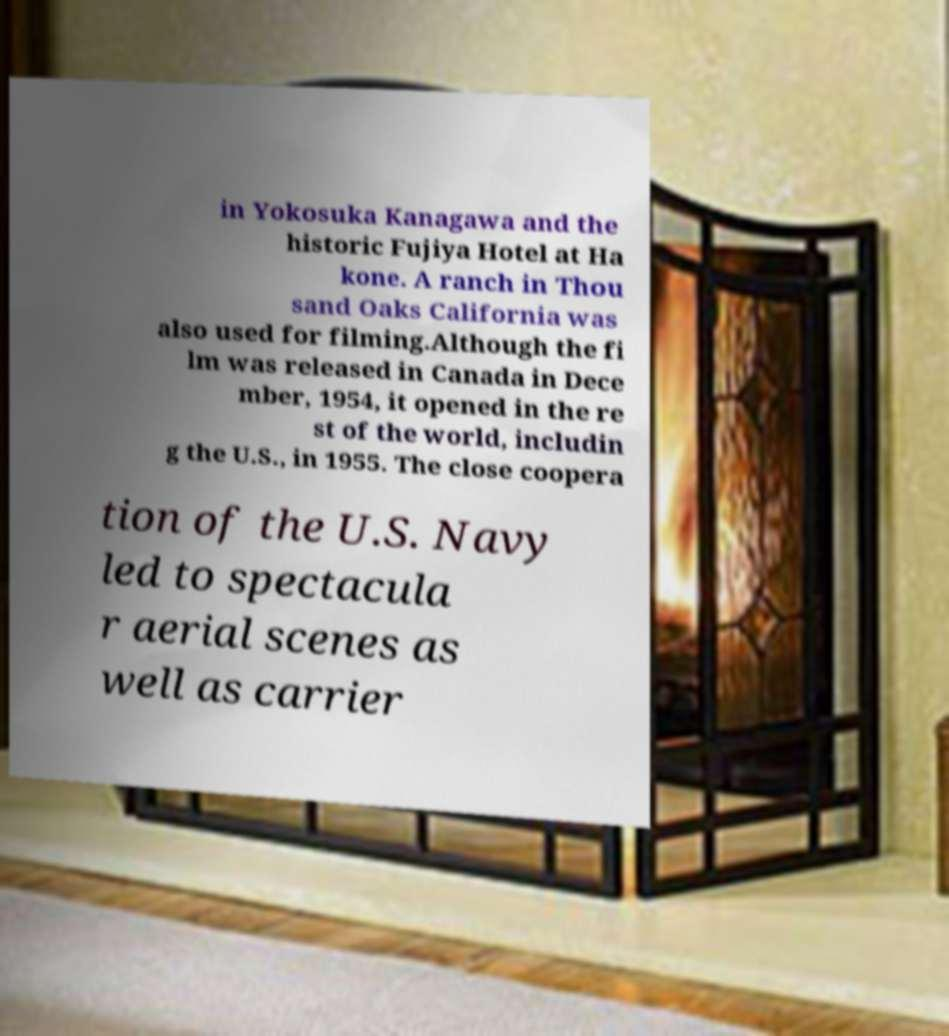Could you extract and type out the text from this image? in Yokosuka Kanagawa and the historic Fujiya Hotel at Ha kone. A ranch in Thou sand Oaks California was also used for filming.Although the fi lm was released in Canada in Dece mber, 1954, it opened in the re st of the world, includin g the U.S., in 1955. The close coopera tion of the U.S. Navy led to spectacula r aerial scenes as well as carrier 